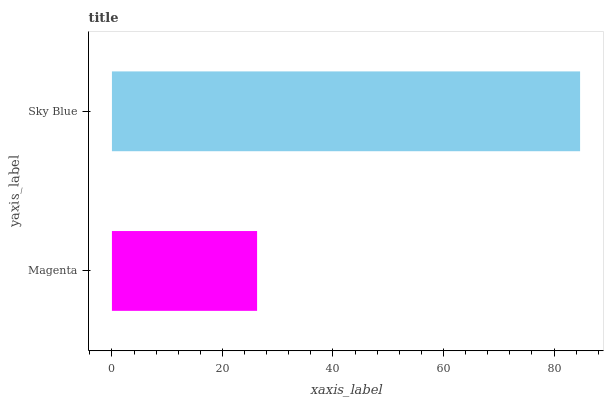Is Magenta the minimum?
Answer yes or no. Yes. Is Sky Blue the maximum?
Answer yes or no. Yes. Is Sky Blue the minimum?
Answer yes or no. No. Is Sky Blue greater than Magenta?
Answer yes or no. Yes. Is Magenta less than Sky Blue?
Answer yes or no. Yes. Is Magenta greater than Sky Blue?
Answer yes or no. No. Is Sky Blue less than Magenta?
Answer yes or no. No. Is Sky Blue the high median?
Answer yes or no. Yes. Is Magenta the low median?
Answer yes or no. Yes. Is Magenta the high median?
Answer yes or no. No. Is Sky Blue the low median?
Answer yes or no. No. 